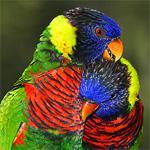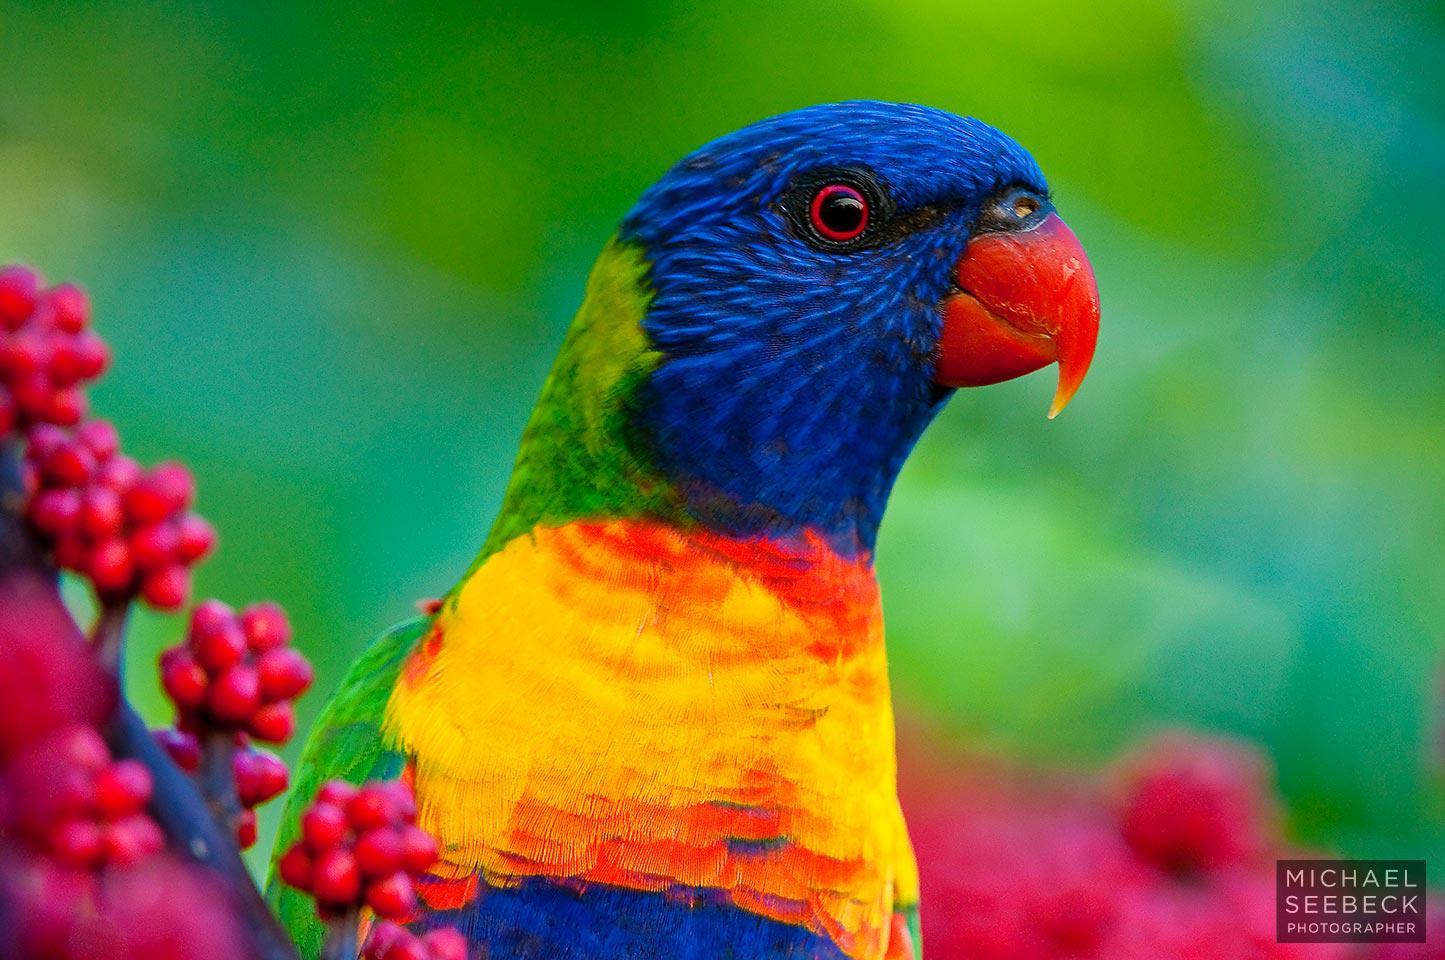The first image is the image on the left, the second image is the image on the right. Analyze the images presented: Is the assertion "At least two parrots are facing left." valid? Answer yes or no. No. The first image is the image on the left, the second image is the image on the right. Assess this claim about the two images: "The left image includes twice as many parrots as the right image.". Correct or not? Answer yes or no. Yes. 